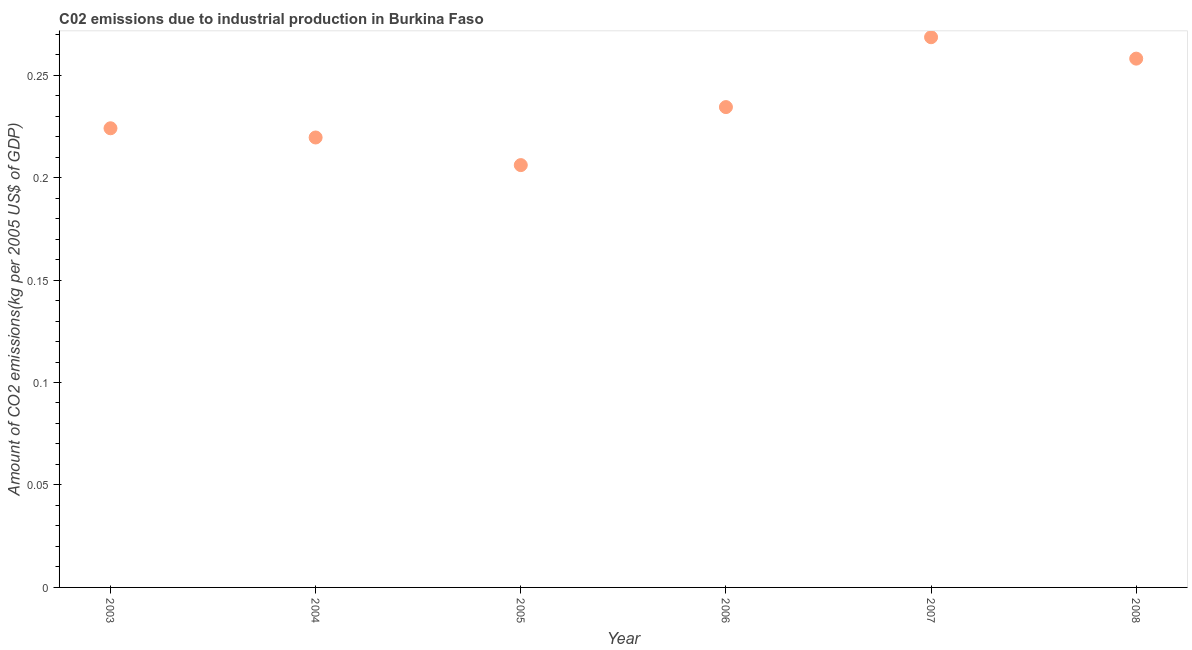What is the amount of co2 emissions in 2003?
Offer a terse response. 0.22. Across all years, what is the maximum amount of co2 emissions?
Give a very brief answer. 0.27. Across all years, what is the minimum amount of co2 emissions?
Your answer should be very brief. 0.21. What is the sum of the amount of co2 emissions?
Provide a succinct answer. 1.41. What is the difference between the amount of co2 emissions in 2003 and 2005?
Your response must be concise. 0.02. What is the average amount of co2 emissions per year?
Offer a terse response. 0.24. What is the median amount of co2 emissions?
Provide a succinct answer. 0.23. In how many years, is the amount of co2 emissions greater than 0.11 kg per 2005 US$ of GDP?
Provide a succinct answer. 6. Do a majority of the years between 2005 and 2008 (inclusive) have amount of co2 emissions greater than 0.14 kg per 2005 US$ of GDP?
Provide a short and direct response. Yes. What is the ratio of the amount of co2 emissions in 2004 to that in 2005?
Ensure brevity in your answer.  1.07. Is the difference between the amount of co2 emissions in 2005 and 2007 greater than the difference between any two years?
Give a very brief answer. Yes. What is the difference between the highest and the second highest amount of co2 emissions?
Provide a succinct answer. 0.01. What is the difference between the highest and the lowest amount of co2 emissions?
Offer a terse response. 0.06. In how many years, is the amount of co2 emissions greater than the average amount of co2 emissions taken over all years?
Your answer should be very brief. 2. Does the amount of co2 emissions monotonically increase over the years?
Offer a terse response. No. How many dotlines are there?
Your answer should be very brief. 1. How many years are there in the graph?
Ensure brevity in your answer.  6. Are the values on the major ticks of Y-axis written in scientific E-notation?
Offer a terse response. No. What is the title of the graph?
Ensure brevity in your answer.  C02 emissions due to industrial production in Burkina Faso. What is the label or title of the X-axis?
Offer a very short reply. Year. What is the label or title of the Y-axis?
Keep it short and to the point. Amount of CO2 emissions(kg per 2005 US$ of GDP). What is the Amount of CO2 emissions(kg per 2005 US$ of GDP) in 2003?
Your answer should be very brief. 0.22. What is the Amount of CO2 emissions(kg per 2005 US$ of GDP) in 2004?
Make the answer very short. 0.22. What is the Amount of CO2 emissions(kg per 2005 US$ of GDP) in 2005?
Provide a succinct answer. 0.21. What is the Amount of CO2 emissions(kg per 2005 US$ of GDP) in 2006?
Offer a very short reply. 0.23. What is the Amount of CO2 emissions(kg per 2005 US$ of GDP) in 2007?
Your response must be concise. 0.27. What is the Amount of CO2 emissions(kg per 2005 US$ of GDP) in 2008?
Provide a succinct answer. 0.26. What is the difference between the Amount of CO2 emissions(kg per 2005 US$ of GDP) in 2003 and 2004?
Provide a short and direct response. 0. What is the difference between the Amount of CO2 emissions(kg per 2005 US$ of GDP) in 2003 and 2005?
Make the answer very short. 0.02. What is the difference between the Amount of CO2 emissions(kg per 2005 US$ of GDP) in 2003 and 2006?
Offer a very short reply. -0.01. What is the difference between the Amount of CO2 emissions(kg per 2005 US$ of GDP) in 2003 and 2007?
Your answer should be very brief. -0.04. What is the difference between the Amount of CO2 emissions(kg per 2005 US$ of GDP) in 2003 and 2008?
Make the answer very short. -0.03. What is the difference between the Amount of CO2 emissions(kg per 2005 US$ of GDP) in 2004 and 2005?
Your answer should be compact. 0.01. What is the difference between the Amount of CO2 emissions(kg per 2005 US$ of GDP) in 2004 and 2006?
Offer a terse response. -0.01. What is the difference between the Amount of CO2 emissions(kg per 2005 US$ of GDP) in 2004 and 2007?
Your answer should be very brief. -0.05. What is the difference between the Amount of CO2 emissions(kg per 2005 US$ of GDP) in 2004 and 2008?
Your answer should be very brief. -0.04. What is the difference between the Amount of CO2 emissions(kg per 2005 US$ of GDP) in 2005 and 2006?
Give a very brief answer. -0.03. What is the difference between the Amount of CO2 emissions(kg per 2005 US$ of GDP) in 2005 and 2007?
Your answer should be compact. -0.06. What is the difference between the Amount of CO2 emissions(kg per 2005 US$ of GDP) in 2005 and 2008?
Provide a succinct answer. -0.05. What is the difference between the Amount of CO2 emissions(kg per 2005 US$ of GDP) in 2006 and 2007?
Your answer should be very brief. -0.03. What is the difference between the Amount of CO2 emissions(kg per 2005 US$ of GDP) in 2006 and 2008?
Keep it short and to the point. -0.02. What is the difference between the Amount of CO2 emissions(kg per 2005 US$ of GDP) in 2007 and 2008?
Provide a succinct answer. 0.01. What is the ratio of the Amount of CO2 emissions(kg per 2005 US$ of GDP) in 2003 to that in 2004?
Give a very brief answer. 1.02. What is the ratio of the Amount of CO2 emissions(kg per 2005 US$ of GDP) in 2003 to that in 2005?
Your answer should be very brief. 1.09. What is the ratio of the Amount of CO2 emissions(kg per 2005 US$ of GDP) in 2003 to that in 2006?
Provide a short and direct response. 0.96. What is the ratio of the Amount of CO2 emissions(kg per 2005 US$ of GDP) in 2003 to that in 2007?
Your answer should be very brief. 0.83. What is the ratio of the Amount of CO2 emissions(kg per 2005 US$ of GDP) in 2003 to that in 2008?
Provide a succinct answer. 0.87. What is the ratio of the Amount of CO2 emissions(kg per 2005 US$ of GDP) in 2004 to that in 2005?
Provide a short and direct response. 1.06. What is the ratio of the Amount of CO2 emissions(kg per 2005 US$ of GDP) in 2004 to that in 2006?
Provide a succinct answer. 0.94. What is the ratio of the Amount of CO2 emissions(kg per 2005 US$ of GDP) in 2004 to that in 2007?
Keep it short and to the point. 0.82. What is the ratio of the Amount of CO2 emissions(kg per 2005 US$ of GDP) in 2004 to that in 2008?
Your answer should be compact. 0.85. What is the ratio of the Amount of CO2 emissions(kg per 2005 US$ of GDP) in 2005 to that in 2006?
Offer a very short reply. 0.88. What is the ratio of the Amount of CO2 emissions(kg per 2005 US$ of GDP) in 2005 to that in 2007?
Provide a succinct answer. 0.77. What is the ratio of the Amount of CO2 emissions(kg per 2005 US$ of GDP) in 2005 to that in 2008?
Your answer should be very brief. 0.8. What is the ratio of the Amount of CO2 emissions(kg per 2005 US$ of GDP) in 2006 to that in 2007?
Ensure brevity in your answer.  0.87. What is the ratio of the Amount of CO2 emissions(kg per 2005 US$ of GDP) in 2006 to that in 2008?
Keep it short and to the point. 0.91. What is the ratio of the Amount of CO2 emissions(kg per 2005 US$ of GDP) in 2007 to that in 2008?
Offer a terse response. 1.04. 